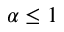<formula> <loc_0><loc_0><loc_500><loc_500>\alpha \leq 1</formula> 